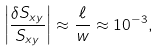Convert formula to latex. <formula><loc_0><loc_0><loc_500><loc_500>\left | \frac { \delta S _ { x y } } { S _ { x y } } \right | \approx \frac { \ell } w \approx 1 0 ^ { - 3 } ,</formula> 